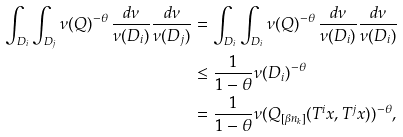<formula> <loc_0><loc_0><loc_500><loc_500>\int _ { D _ { i } } \int _ { D _ { j } } \nu ( Q ) ^ { - \theta } \, \frac { d \nu } { \nu ( D _ { i } ) } \frac { d \nu } { \nu ( D _ { j } ) } & = \int _ { D _ { i } } \int _ { D _ { i } } \nu ( Q ) ^ { - \theta } \, \frac { d \nu } { \nu ( D _ { i } ) } \frac { d \nu } { \nu ( D _ { i } ) } \\ & \leq \frac { 1 } { 1 - \theta } \nu ( D _ { i } ) ^ { - \theta } \\ & = \frac { 1 } { 1 - \theta } \nu ( Q _ { [ \beta n _ { k } ] } ( T ^ { i } x , T ^ { j } x ) ) ^ { - \theta } ,</formula> 